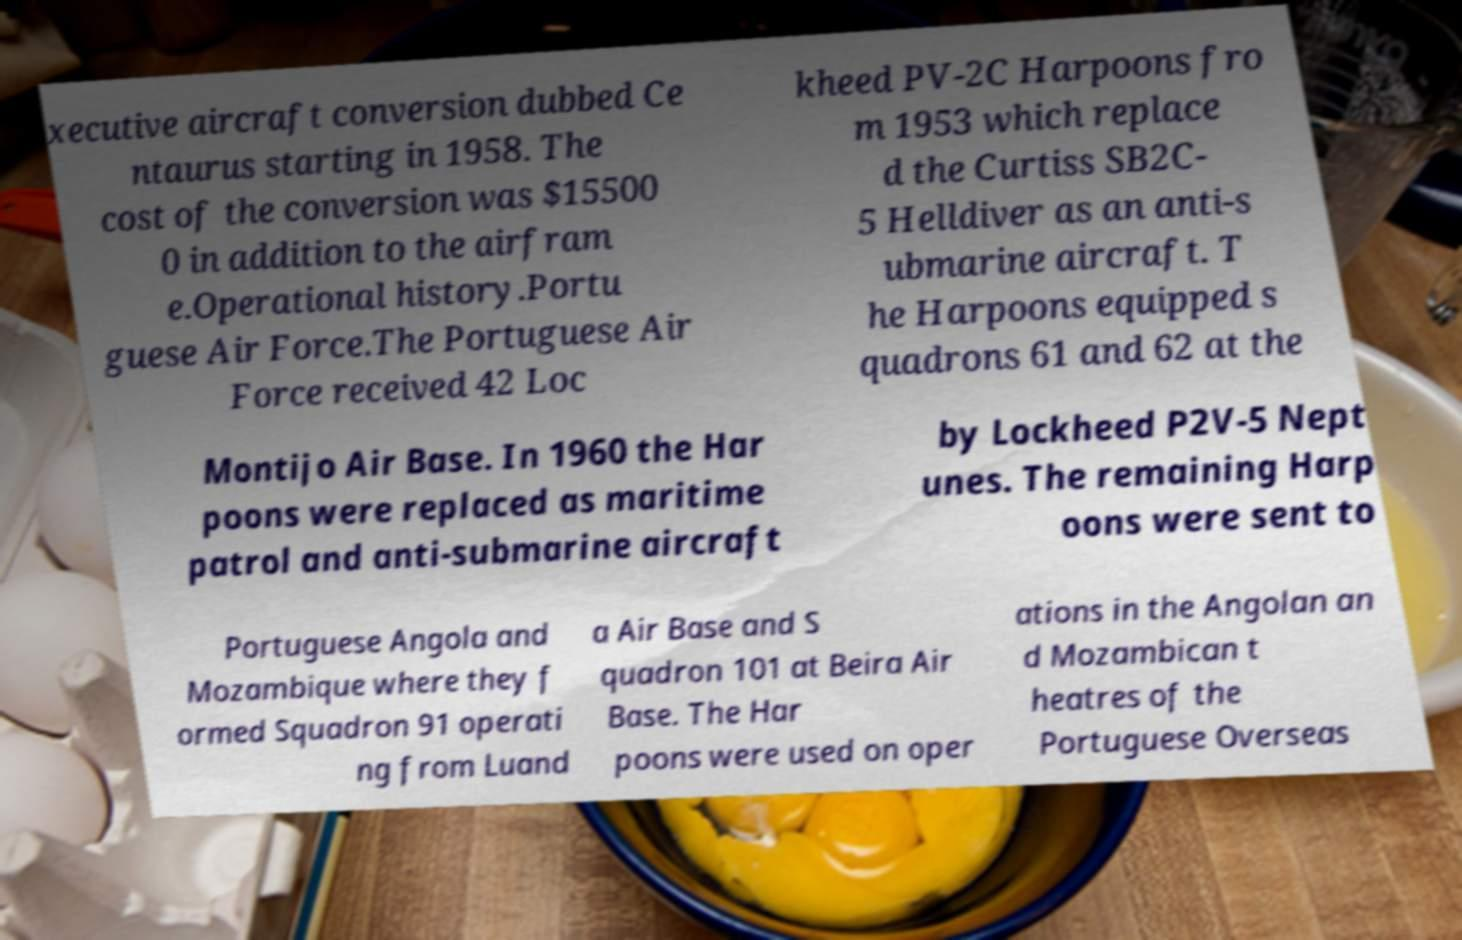Could you assist in decoding the text presented in this image and type it out clearly? xecutive aircraft conversion dubbed Ce ntaurus starting in 1958. The cost of the conversion was $15500 0 in addition to the airfram e.Operational history.Portu guese Air Force.The Portuguese Air Force received 42 Loc kheed PV-2C Harpoons fro m 1953 which replace d the Curtiss SB2C- 5 Helldiver as an anti-s ubmarine aircraft. T he Harpoons equipped s quadrons 61 and 62 at the Montijo Air Base. In 1960 the Har poons were replaced as maritime patrol and anti-submarine aircraft by Lockheed P2V-5 Nept unes. The remaining Harp oons were sent to Portuguese Angola and Mozambique where they f ormed Squadron 91 operati ng from Luand a Air Base and S quadron 101 at Beira Air Base. The Har poons were used on oper ations in the Angolan an d Mozambican t heatres of the Portuguese Overseas 